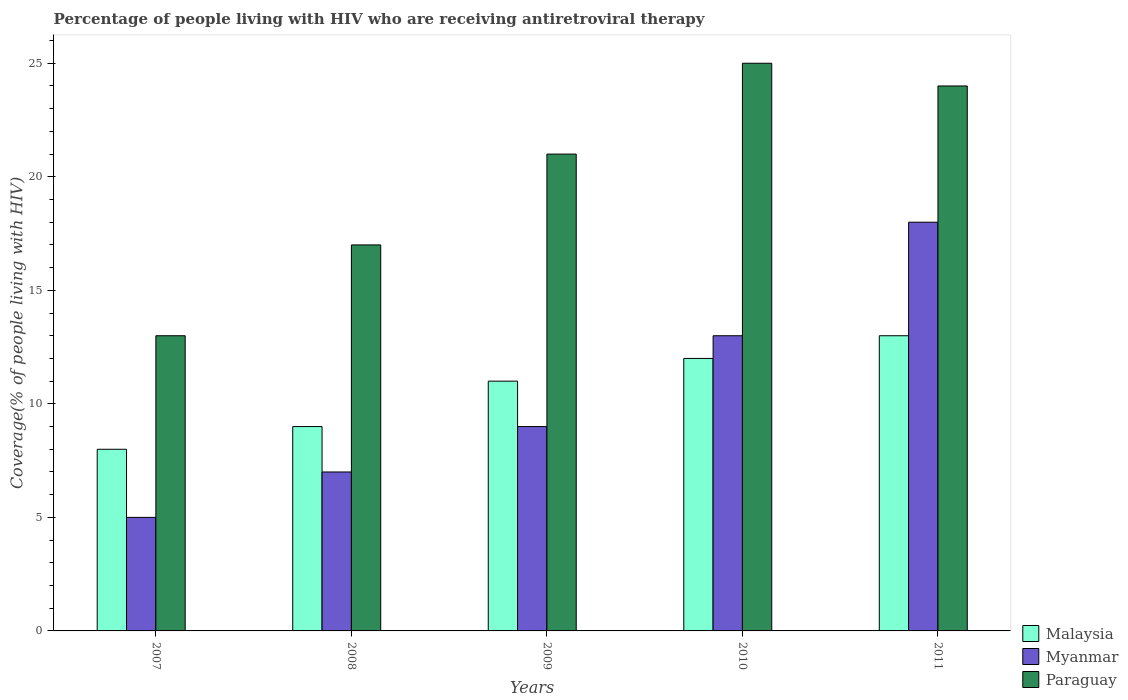How many different coloured bars are there?
Provide a succinct answer. 3. How many groups of bars are there?
Make the answer very short. 5. Are the number of bars per tick equal to the number of legend labels?
Ensure brevity in your answer.  Yes. How many bars are there on the 5th tick from the left?
Provide a succinct answer. 3. In how many cases, is the number of bars for a given year not equal to the number of legend labels?
Your answer should be very brief. 0. What is the percentage of the HIV infected people who are receiving antiretroviral therapy in Paraguay in 2007?
Ensure brevity in your answer.  13. Across all years, what is the maximum percentage of the HIV infected people who are receiving antiretroviral therapy in Myanmar?
Your answer should be compact. 18. Across all years, what is the minimum percentage of the HIV infected people who are receiving antiretroviral therapy in Myanmar?
Your answer should be compact. 5. In which year was the percentage of the HIV infected people who are receiving antiretroviral therapy in Malaysia minimum?
Give a very brief answer. 2007. What is the total percentage of the HIV infected people who are receiving antiretroviral therapy in Myanmar in the graph?
Your answer should be very brief. 52. What is the difference between the percentage of the HIV infected people who are receiving antiretroviral therapy in Myanmar in 2007 and that in 2009?
Ensure brevity in your answer.  -4. What is the difference between the percentage of the HIV infected people who are receiving antiretroviral therapy in Myanmar in 2010 and the percentage of the HIV infected people who are receiving antiretroviral therapy in Paraguay in 2009?
Offer a very short reply. -8. In the year 2010, what is the difference between the percentage of the HIV infected people who are receiving antiretroviral therapy in Paraguay and percentage of the HIV infected people who are receiving antiretroviral therapy in Myanmar?
Your answer should be compact. 12. What is the ratio of the percentage of the HIV infected people who are receiving antiretroviral therapy in Malaysia in 2008 to that in 2011?
Give a very brief answer. 0.69. Is the percentage of the HIV infected people who are receiving antiretroviral therapy in Myanmar in 2007 less than that in 2011?
Keep it short and to the point. Yes. What is the difference between the highest and the lowest percentage of the HIV infected people who are receiving antiretroviral therapy in Myanmar?
Make the answer very short. 13. Is the sum of the percentage of the HIV infected people who are receiving antiretroviral therapy in Myanmar in 2008 and 2009 greater than the maximum percentage of the HIV infected people who are receiving antiretroviral therapy in Paraguay across all years?
Your answer should be compact. No. What does the 2nd bar from the left in 2007 represents?
Your answer should be compact. Myanmar. What does the 2nd bar from the right in 2010 represents?
Offer a very short reply. Myanmar. Are all the bars in the graph horizontal?
Keep it short and to the point. No. Does the graph contain grids?
Your response must be concise. No. Where does the legend appear in the graph?
Make the answer very short. Bottom right. How many legend labels are there?
Your answer should be compact. 3. What is the title of the graph?
Make the answer very short. Percentage of people living with HIV who are receiving antiretroviral therapy. What is the label or title of the Y-axis?
Offer a very short reply. Coverage(% of people living with HIV). What is the Coverage(% of people living with HIV) in Malaysia in 2007?
Your response must be concise. 8. What is the Coverage(% of people living with HIV) in Paraguay in 2007?
Give a very brief answer. 13. What is the Coverage(% of people living with HIV) in Paraguay in 2009?
Provide a succinct answer. 21. What is the Coverage(% of people living with HIV) in Malaysia in 2010?
Give a very brief answer. 12. What is the Coverage(% of people living with HIV) in Malaysia in 2011?
Give a very brief answer. 13. What is the Coverage(% of people living with HIV) of Myanmar in 2011?
Offer a very short reply. 18. Across all years, what is the maximum Coverage(% of people living with HIV) of Myanmar?
Your answer should be compact. 18. Across all years, what is the maximum Coverage(% of people living with HIV) of Paraguay?
Your response must be concise. 25. What is the total Coverage(% of people living with HIV) in Myanmar in the graph?
Your response must be concise. 52. What is the difference between the Coverage(% of people living with HIV) in Malaysia in 2007 and that in 2008?
Keep it short and to the point. -1. What is the difference between the Coverage(% of people living with HIV) of Myanmar in 2007 and that in 2008?
Make the answer very short. -2. What is the difference between the Coverage(% of people living with HIV) of Paraguay in 2007 and that in 2008?
Your response must be concise. -4. What is the difference between the Coverage(% of people living with HIV) of Malaysia in 2007 and that in 2009?
Offer a very short reply. -3. What is the difference between the Coverage(% of people living with HIV) in Myanmar in 2007 and that in 2009?
Offer a very short reply. -4. What is the difference between the Coverage(% of people living with HIV) in Malaysia in 2007 and that in 2010?
Offer a terse response. -4. What is the difference between the Coverage(% of people living with HIV) in Paraguay in 2007 and that in 2010?
Keep it short and to the point. -12. What is the difference between the Coverage(% of people living with HIV) in Myanmar in 2007 and that in 2011?
Make the answer very short. -13. What is the difference between the Coverage(% of people living with HIV) in Paraguay in 2007 and that in 2011?
Make the answer very short. -11. What is the difference between the Coverage(% of people living with HIV) in Malaysia in 2008 and that in 2009?
Your answer should be very brief. -2. What is the difference between the Coverage(% of people living with HIV) of Myanmar in 2008 and that in 2009?
Offer a very short reply. -2. What is the difference between the Coverage(% of people living with HIV) in Malaysia in 2008 and that in 2010?
Make the answer very short. -3. What is the difference between the Coverage(% of people living with HIV) of Myanmar in 2008 and that in 2010?
Ensure brevity in your answer.  -6. What is the difference between the Coverage(% of people living with HIV) in Paraguay in 2008 and that in 2010?
Provide a succinct answer. -8. What is the difference between the Coverage(% of people living with HIV) in Malaysia in 2008 and that in 2011?
Provide a short and direct response. -4. What is the difference between the Coverage(% of people living with HIV) in Myanmar in 2008 and that in 2011?
Your answer should be very brief. -11. What is the difference between the Coverage(% of people living with HIV) in Paraguay in 2008 and that in 2011?
Make the answer very short. -7. What is the difference between the Coverage(% of people living with HIV) of Myanmar in 2009 and that in 2010?
Provide a short and direct response. -4. What is the difference between the Coverage(% of people living with HIV) in Paraguay in 2009 and that in 2010?
Ensure brevity in your answer.  -4. What is the difference between the Coverage(% of people living with HIV) of Malaysia in 2010 and that in 2011?
Ensure brevity in your answer.  -1. What is the difference between the Coverage(% of people living with HIV) in Myanmar in 2010 and that in 2011?
Your response must be concise. -5. What is the difference between the Coverage(% of people living with HIV) of Myanmar in 2007 and the Coverage(% of people living with HIV) of Paraguay in 2008?
Make the answer very short. -12. What is the difference between the Coverage(% of people living with HIV) in Malaysia in 2007 and the Coverage(% of people living with HIV) in Paraguay in 2009?
Give a very brief answer. -13. What is the difference between the Coverage(% of people living with HIV) of Myanmar in 2007 and the Coverage(% of people living with HIV) of Paraguay in 2009?
Your answer should be compact. -16. What is the difference between the Coverage(% of people living with HIV) in Malaysia in 2007 and the Coverage(% of people living with HIV) in Myanmar in 2010?
Keep it short and to the point. -5. What is the difference between the Coverage(% of people living with HIV) of Malaysia in 2007 and the Coverage(% of people living with HIV) of Paraguay in 2010?
Offer a very short reply. -17. What is the difference between the Coverage(% of people living with HIV) of Malaysia in 2008 and the Coverage(% of people living with HIV) of Myanmar in 2009?
Your response must be concise. 0. What is the difference between the Coverage(% of people living with HIV) of Myanmar in 2008 and the Coverage(% of people living with HIV) of Paraguay in 2009?
Your response must be concise. -14. What is the difference between the Coverage(% of people living with HIV) of Malaysia in 2008 and the Coverage(% of people living with HIV) of Myanmar in 2010?
Provide a short and direct response. -4. What is the difference between the Coverage(% of people living with HIV) in Malaysia in 2008 and the Coverage(% of people living with HIV) in Paraguay in 2010?
Make the answer very short. -16. What is the difference between the Coverage(% of people living with HIV) in Malaysia in 2008 and the Coverage(% of people living with HIV) in Myanmar in 2011?
Make the answer very short. -9. What is the difference between the Coverage(% of people living with HIV) of Malaysia in 2008 and the Coverage(% of people living with HIV) of Paraguay in 2011?
Your answer should be compact. -15. What is the difference between the Coverage(% of people living with HIV) in Malaysia in 2009 and the Coverage(% of people living with HIV) in Myanmar in 2010?
Your answer should be compact. -2. What is the difference between the Coverage(% of people living with HIV) of Malaysia in 2009 and the Coverage(% of people living with HIV) of Paraguay in 2010?
Offer a very short reply. -14. What is the difference between the Coverage(% of people living with HIV) of Myanmar in 2009 and the Coverage(% of people living with HIV) of Paraguay in 2010?
Provide a short and direct response. -16. What is the difference between the Coverage(% of people living with HIV) of Malaysia in 2009 and the Coverage(% of people living with HIV) of Myanmar in 2011?
Your response must be concise. -7. What is the difference between the Coverage(% of people living with HIV) of Malaysia in 2009 and the Coverage(% of people living with HIV) of Paraguay in 2011?
Your answer should be compact. -13. What is the difference between the Coverage(% of people living with HIV) of Malaysia in 2010 and the Coverage(% of people living with HIV) of Myanmar in 2011?
Provide a succinct answer. -6. What is the difference between the Coverage(% of people living with HIV) in Malaysia in 2010 and the Coverage(% of people living with HIV) in Paraguay in 2011?
Offer a terse response. -12. What is the difference between the Coverage(% of people living with HIV) of Myanmar in 2010 and the Coverage(% of people living with HIV) of Paraguay in 2011?
Provide a succinct answer. -11. What is the average Coverage(% of people living with HIV) of Paraguay per year?
Provide a succinct answer. 20. In the year 2008, what is the difference between the Coverage(% of people living with HIV) in Malaysia and Coverage(% of people living with HIV) in Myanmar?
Provide a succinct answer. 2. In the year 2008, what is the difference between the Coverage(% of people living with HIV) in Myanmar and Coverage(% of people living with HIV) in Paraguay?
Ensure brevity in your answer.  -10. In the year 2009, what is the difference between the Coverage(% of people living with HIV) of Malaysia and Coverage(% of people living with HIV) of Paraguay?
Your answer should be very brief. -10. In the year 2009, what is the difference between the Coverage(% of people living with HIV) of Myanmar and Coverage(% of people living with HIV) of Paraguay?
Give a very brief answer. -12. In the year 2010, what is the difference between the Coverage(% of people living with HIV) in Malaysia and Coverage(% of people living with HIV) in Myanmar?
Your answer should be very brief. -1. In the year 2010, what is the difference between the Coverage(% of people living with HIV) in Malaysia and Coverage(% of people living with HIV) in Paraguay?
Your answer should be compact. -13. In the year 2011, what is the difference between the Coverage(% of people living with HIV) in Malaysia and Coverage(% of people living with HIV) in Myanmar?
Make the answer very short. -5. What is the ratio of the Coverage(% of people living with HIV) of Paraguay in 2007 to that in 2008?
Offer a very short reply. 0.76. What is the ratio of the Coverage(% of people living with HIV) of Malaysia in 2007 to that in 2009?
Offer a terse response. 0.73. What is the ratio of the Coverage(% of people living with HIV) in Myanmar in 2007 to that in 2009?
Offer a terse response. 0.56. What is the ratio of the Coverage(% of people living with HIV) of Paraguay in 2007 to that in 2009?
Give a very brief answer. 0.62. What is the ratio of the Coverage(% of people living with HIV) of Myanmar in 2007 to that in 2010?
Keep it short and to the point. 0.38. What is the ratio of the Coverage(% of people living with HIV) in Paraguay in 2007 to that in 2010?
Offer a terse response. 0.52. What is the ratio of the Coverage(% of people living with HIV) in Malaysia in 2007 to that in 2011?
Your answer should be very brief. 0.62. What is the ratio of the Coverage(% of people living with HIV) of Myanmar in 2007 to that in 2011?
Your response must be concise. 0.28. What is the ratio of the Coverage(% of people living with HIV) of Paraguay in 2007 to that in 2011?
Your response must be concise. 0.54. What is the ratio of the Coverage(% of people living with HIV) of Malaysia in 2008 to that in 2009?
Provide a short and direct response. 0.82. What is the ratio of the Coverage(% of people living with HIV) of Paraguay in 2008 to that in 2009?
Offer a terse response. 0.81. What is the ratio of the Coverage(% of people living with HIV) of Myanmar in 2008 to that in 2010?
Your answer should be very brief. 0.54. What is the ratio of the Coverage(% of people living with HIV) of Paraguay in 2008 to that in 2010?
Your response must be concise. 0.68. What is the ratio of the Coverage(% of people living with HIV) in Malaysia in 2008 to that in 2011?
Offer a terse response. 0.69. What is the ratio of the Coverage(% of people living with HIV) in Myanmar in 2008 to that in 2011?
Make the answer very short. 0.39. What is the ratio of the Coverage(% of people living with HIV) in Paraguay in 2008 to that in 2011?
Your answer should be compact. 0.71. What is the ratio of the Coverage(% of people living with HIV) of Myanmar in 2009 to that in 2010?
Offer a very short reply. 0.69. What is the ratio of the Coverage(% of people living with HIV) of Paraguay in 2009 to that in 2010?
Make the answer very short. 0.84. What is the ratio of the Coverage(% of people living with HIV) of Malaysia in 2009 to that in 2011?
Your response must be concise. 0.85. What is the ratio of the Coverage(% of people living with HIV) of Myanmar in 2010 to that in 2011?
Provide a short and direct response. 0.72. What is the ratio of the Coverage(% of people living with HIV) of Paraguay in 2010 to that in 2011?
Your answer should be very brief. 1.04. What is the difference between the highest and the second highest Coverage(% of people living with HIV) in Malaysia?
Keep it short and to the point. 1. What is the difference between the highest and the second highest Coverage(% of people living with HIV) in Myanmar?
Provide a succinct answer. 5. What is the difference between the highest and the second highest Coverage(% of people living with HIV) in Paraguay?
Give a very brief answer. 1. 